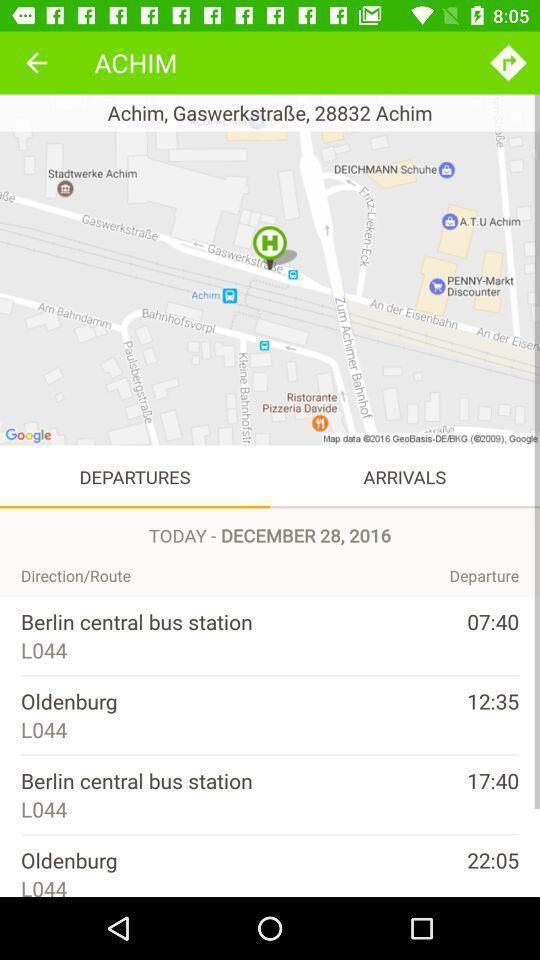Describe the content in this image. Screen showing list of departures in travel app. 